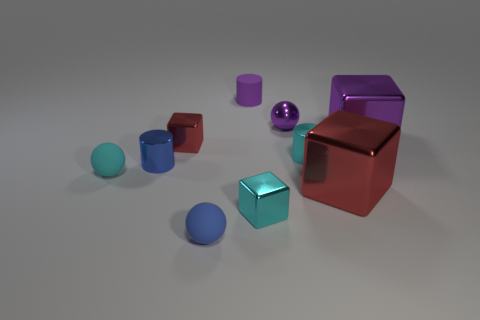Are there any tiny purple cylinders to the left of the small cyan metal cylinder?
Your response must be concise. Yes. There is a purple thing that is the same material as the purple ball; what is its size?
Keep it short and to the point. Large. What number of other shiny things are the same shape as the big red object?
Ensure brevity in your answer.  3. Are the purple block and the small ball in front of the small cyan matte object made of the same material?
Your response must be concise. No. Are there more metallic cylinders to the left of the small cyan metal cube than large red rubber blocks?
Offer a terse response. Yes. There is a large thing that is the same color as the small metal ball; what is its shape?
Provide a succinct answer. Cube. Is there another large thing made of the same material as the big red object?
Keep it short and to the point. Yes. Does the small purple object that is in front of the rubber cylinder have the same material as the small cyan sphere that is on the left side of the tiny red shiny thing?
Give a very brief answer. No. Are there an equal number of large red objects behind the small red cube and small metal objects right of the tiny blue matte ball?
Keep it short and to the point. No. The other shiny cube that is the same size as the purple metallic cube is what color?
Provide a succinct answer. Red. 